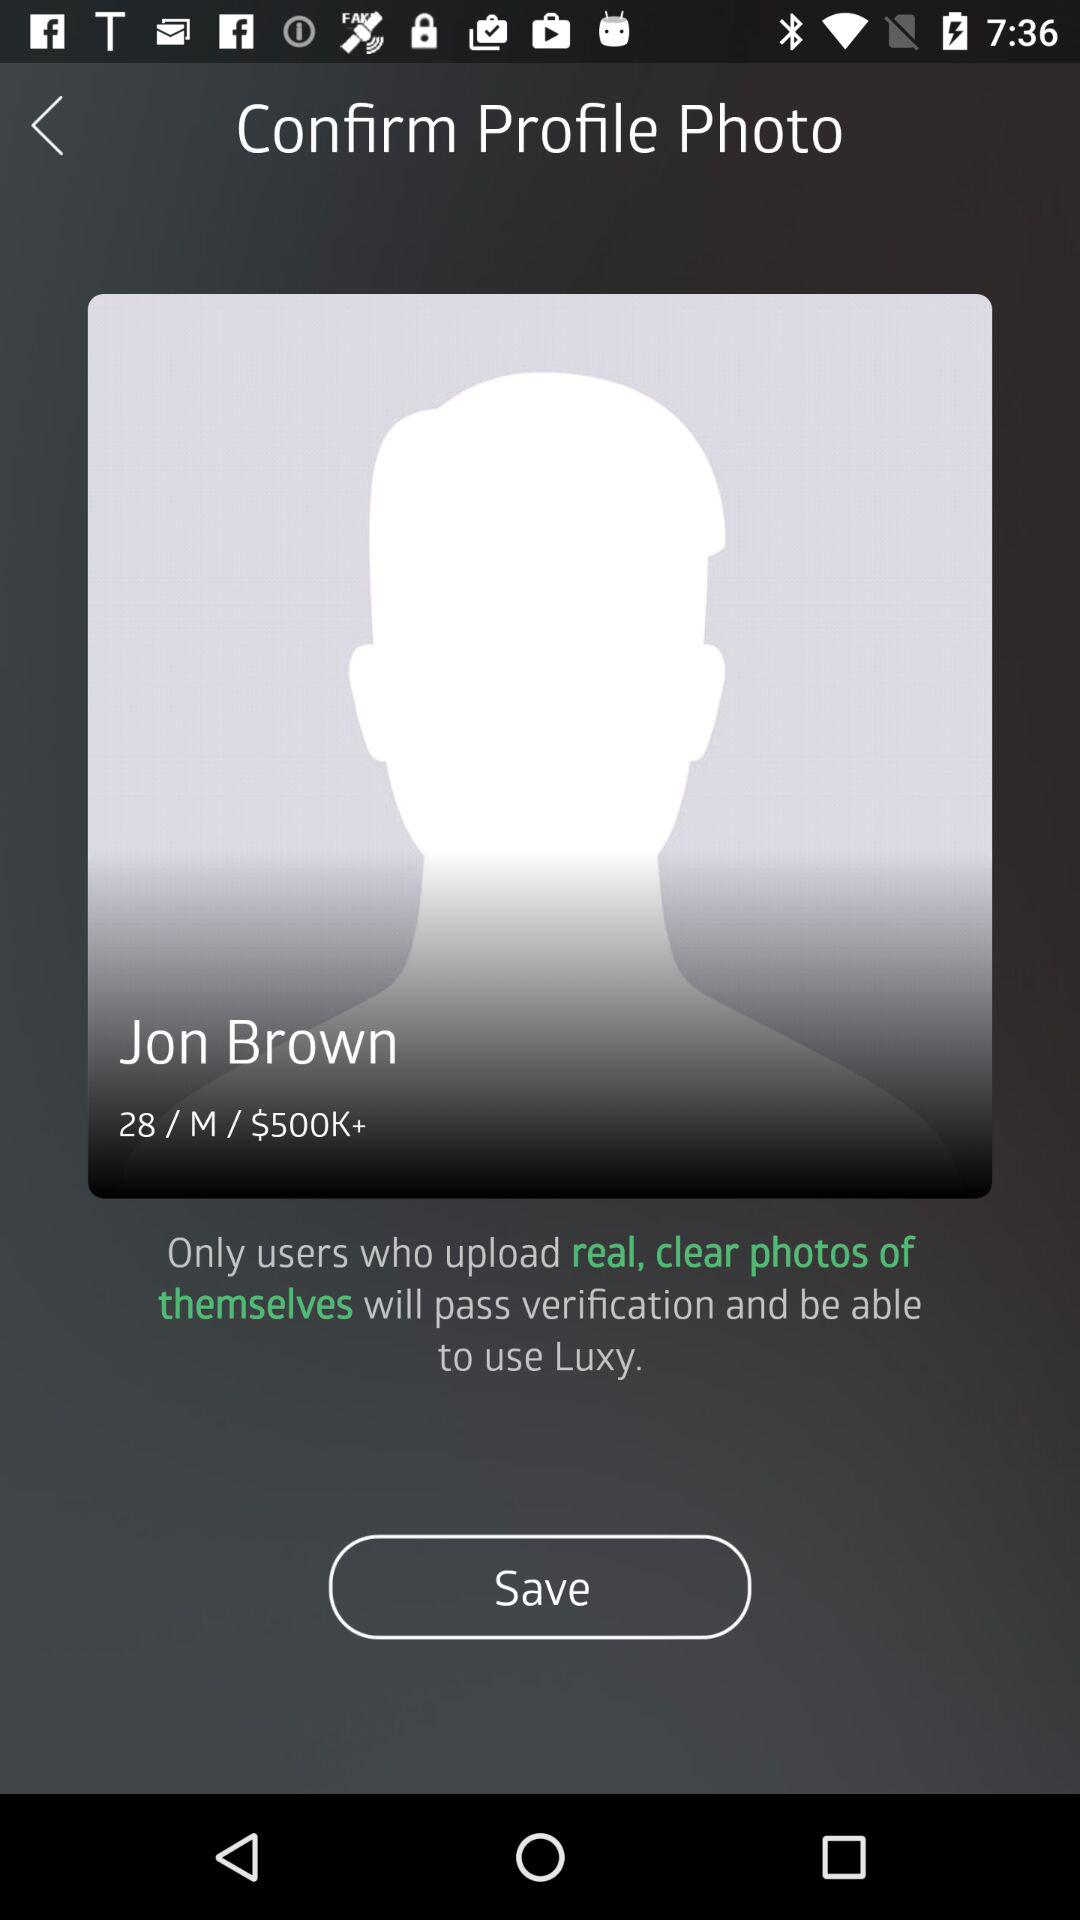What is the user name? The user name is Jon Brown. 